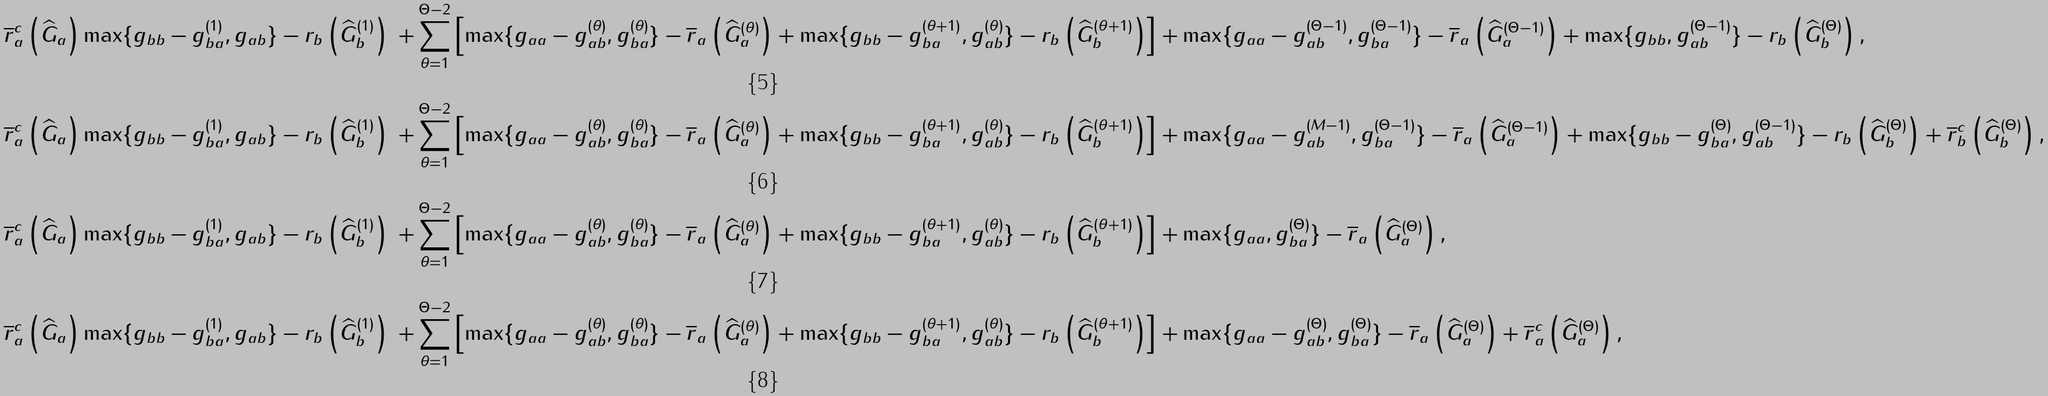Convert formula to latex. <formula><loc_0><loc_0><loc_500><loc_500>\overline { r } _ { a } ^ { c } \left ( \widehat { G } _ { a } \right ) & \max \{ g _ { b b } - g _ { b a } ^ { ( 1 ) } , g _ { a b } \} - r _ { b } \left ( \widehat { G } _ { b } ^ { ( 1 ) } \right ) & + \sum _ { \theta = 1 } ^ { \Theta - 2 } \left [ \max \{ g _ { a a } - g _ { a b } ^ { ( \theta ) } , g _ { b a } ^ { ( \theta ) } \} - \overline { r } _ { a } \left ( \widehat { G } _ { a } ^ { ( \theta ) } \right ) + \max \{ g _ { b b } - g _ { b a } ^ { ( \theta + 1 ) } , g _ { a b } ^ { ( \theta ) } \} - r _ { b } \left ( \widehat { G } _ { b } ^ { ( \theta + 1 ) } \right ) \right ] & + \max \{ g _ { a a } - g _ { a b } ^ { ( \Theta - 1 ) } , g _ { b a } ^ { ( \Theta - 1 ) } \} - \overline { r } _ { a } \left ( \widehat { G } _ { a } ^ { ( \Theta - 1 ) } \right ) + \max \{ g _ { b b } , g _ { a b } ^ { ( \Theta - 1 ) } \} - r _ { b } \left ( \widehat { G } _ { b } ^ { ( \Theta ) } \right ) , \\ \overline { r } _ { a } ^ { c } \left ( \widehat { G } _ { a } \right ) & \max \{ g _ { b b } - g _ { b a } ^ { ( 1 ) } , g _ { a b } \} - r _ { b } \left ( \widehat { G } _ { b } ^ { ( 1 ) } \right ) & + \sum _ { \theta = 1 } ^ { \Theta - 2 } \left [ \max \{ g _ { a a } - g _ { a b } ^ { ( \theta ) } , g _ { b a } ^ { ( \theta ) } \} - \overline { r } _ { a } \left ( \widehat { G } _ { a } ^ { ( \theta ) } \right ) + \max \{ g _ { b b } - g _ { b a } ^ { ( \theta + 1 ) } , g _ { a b } ^ { ( \theta ) } \} - r _ { b } \left ( \widehat { G } _ { b } ^ { ( \theta + 1 ) } \right ) \right ] & + \max \{ g _ { a a } - g _ { a b } ^ { ( M - 1 ) } , g _ { b a } ^ { ( \Theta - 1 ) } \} - \overline { r } _ { a } \left ( \widehat { G } _ { a } ^ { ( \Theta - 1 ) } \right ) + \max \{ g _ { b b } - g _ { b a } ^ { ( \Theta ) } , g _ { a b } ^ { ( \Theta - 1 ) } \} - r _ { b } \left ( \widehat { G } _ { b } ^ { ( \Theta ) } \right ) + \overline { r } _ { b } ^ { c } \left ( \widehat { G } _ { b } ^ { ( \Theta ) } \right ) , \\ \overline { r } _ { a } ^ { c } \left ( \widehat { G } _ { a } \right ) & \max \{ g _ { b b } - g _ { b a } ^ { ( 1 ) } , g _ { a b } \} - r _ { b } \left ( \widehat { G } _ { b } ^ { ( 1 ) } \right ) & + \sum _ { \theta = 1 } ^ { \Theta - 2 } \left [ \max \{ g _ { a a } - g _ { a b } ^ { ( \theta ) } , g _ { b a } ^ { ( \theta ) } \} - \overline { r } _ { a } \left ( \widehat { G } _ { a } ^ { ( \theta ) } \right ) + \max \{ g _ { b b } - g _ { b a } ^ { ( \theta + 1 ) } , g _ { a b } ^ { ( \theta ) } \} - r _ { b } \left ( \widehat { G } _ { b } ^ { ( \theta + 1 ) } \right ) \right ] & + \max \{ g _ { a a } , g _ { b a } ^ { ( \Theta ) } \} - \overline { r } _ { a } \left ( \widehat { G } _ { a } ^ { ( \Theta ) } \right ) , \\ \overline { r } _ { a } ^ { c } \left ( \widehat { G } _ { a } \right ) & \max \{ g _ { b b } - g _ { b a } ^ { ( 1 ) } , g _ { a b } \} - r _ { b } \left ( \widehat { G } _ { b } ^ { ( 1 ) } \right ) & + \sum _ { \theta = 1 } ^ { \Theta - 2 } \left [ \max \{ g _ { a a } - g _ { a b } ^ { ( \theta ) } , g _ { b a } ^ { ( \theta ) } \} - \overline { r } _ { a } \left ( \widehat { G } _ { a } ^ { ( \theta ) } \right ) + \max \{ g _ { b b } - g _ { b a } ^ { ( \theta + 1 ) } , g _ { a b } ^ { ( \theta ) } \} - r _ { b } \left ( \widehat { G } _ { b } ^ { ( \theta + 1 ) } \right ) \right ] & + \max \{ g _ { a a } - g _ { a b } ^ { ( \Theta ) } , g _ { b a } ^ { ( \Theta ) } \} - \overline { r } _ { a } \left ( \widehat { G } _ { a } ^ { ( \Theta ) } \right ) + \overline { r } _ { a } ^ { c } \left ( \widehat { G } _ { a } ^ { ( \Theta ) } \right ) ,</formula> 